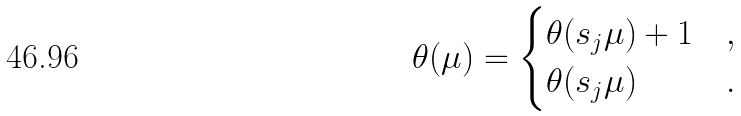<formula> <loc_0><loc_0><loc_500><loc_500>\theta ( \mu ) = \begin{cases} \theta ( s _ { j } \mu ) + 1 & , \\ \theta ( s _ { j } \mu ) & . \end{cases}</formula> 